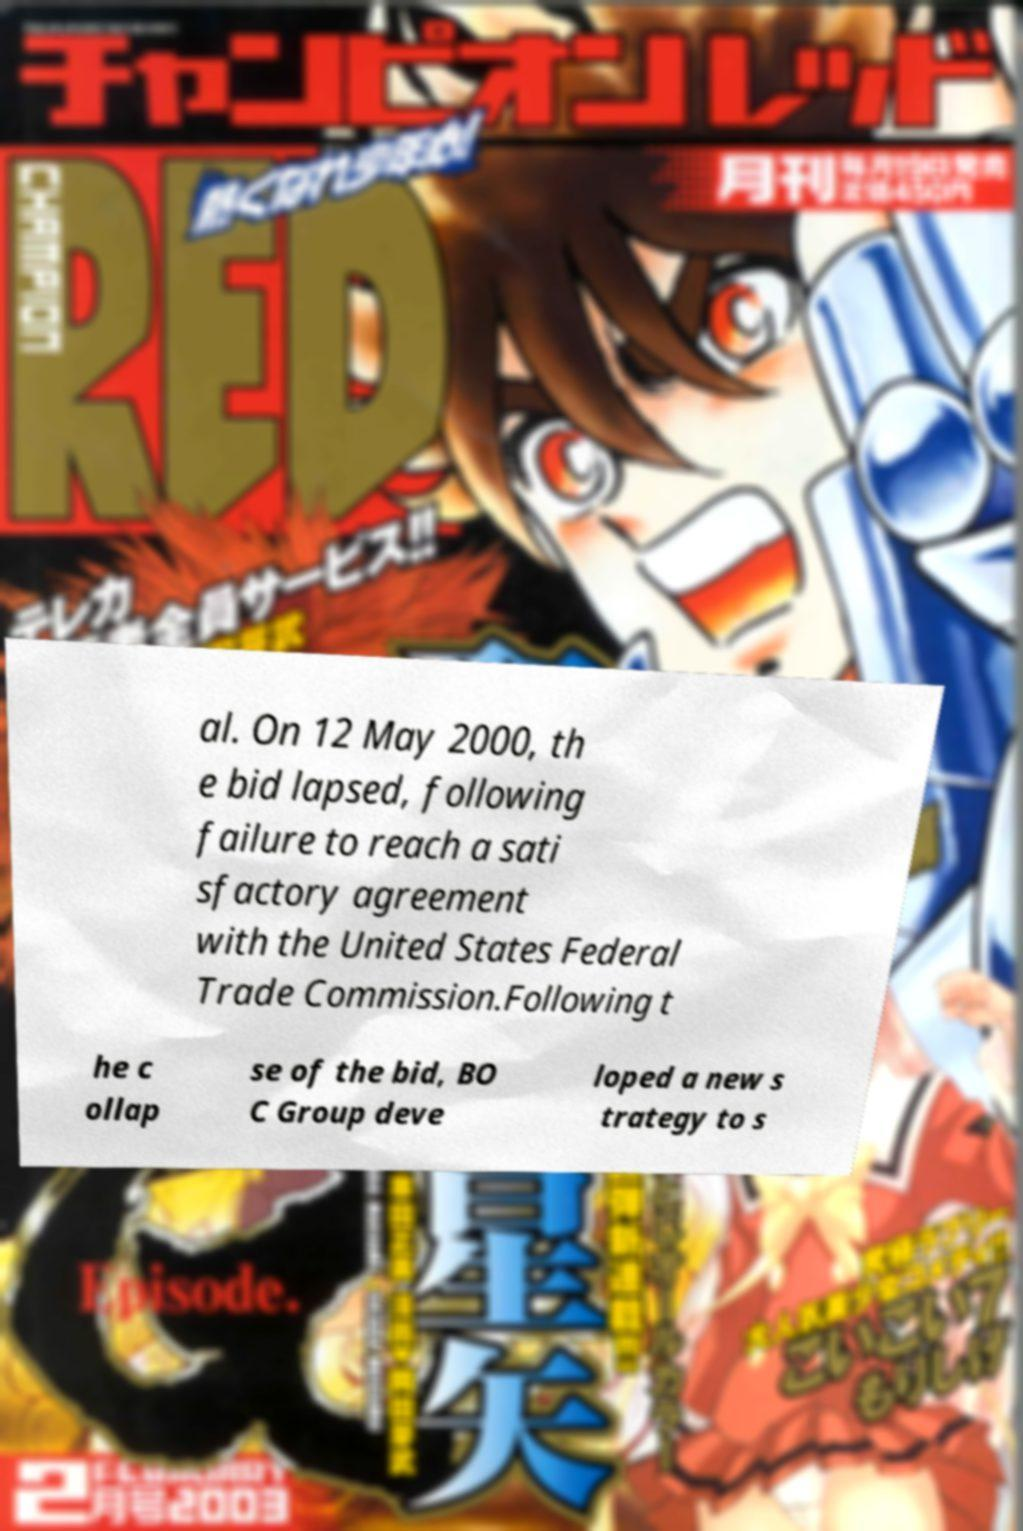Please identify and transcribe the text found in this image. al. On 12 May 2000, th e bid lapsed, following failure to reach a sati sfactory agreement with the United States Federal Trade Commission.Following t he c ollap se of the bid, BO C Group deve loped a new s trategy to s 